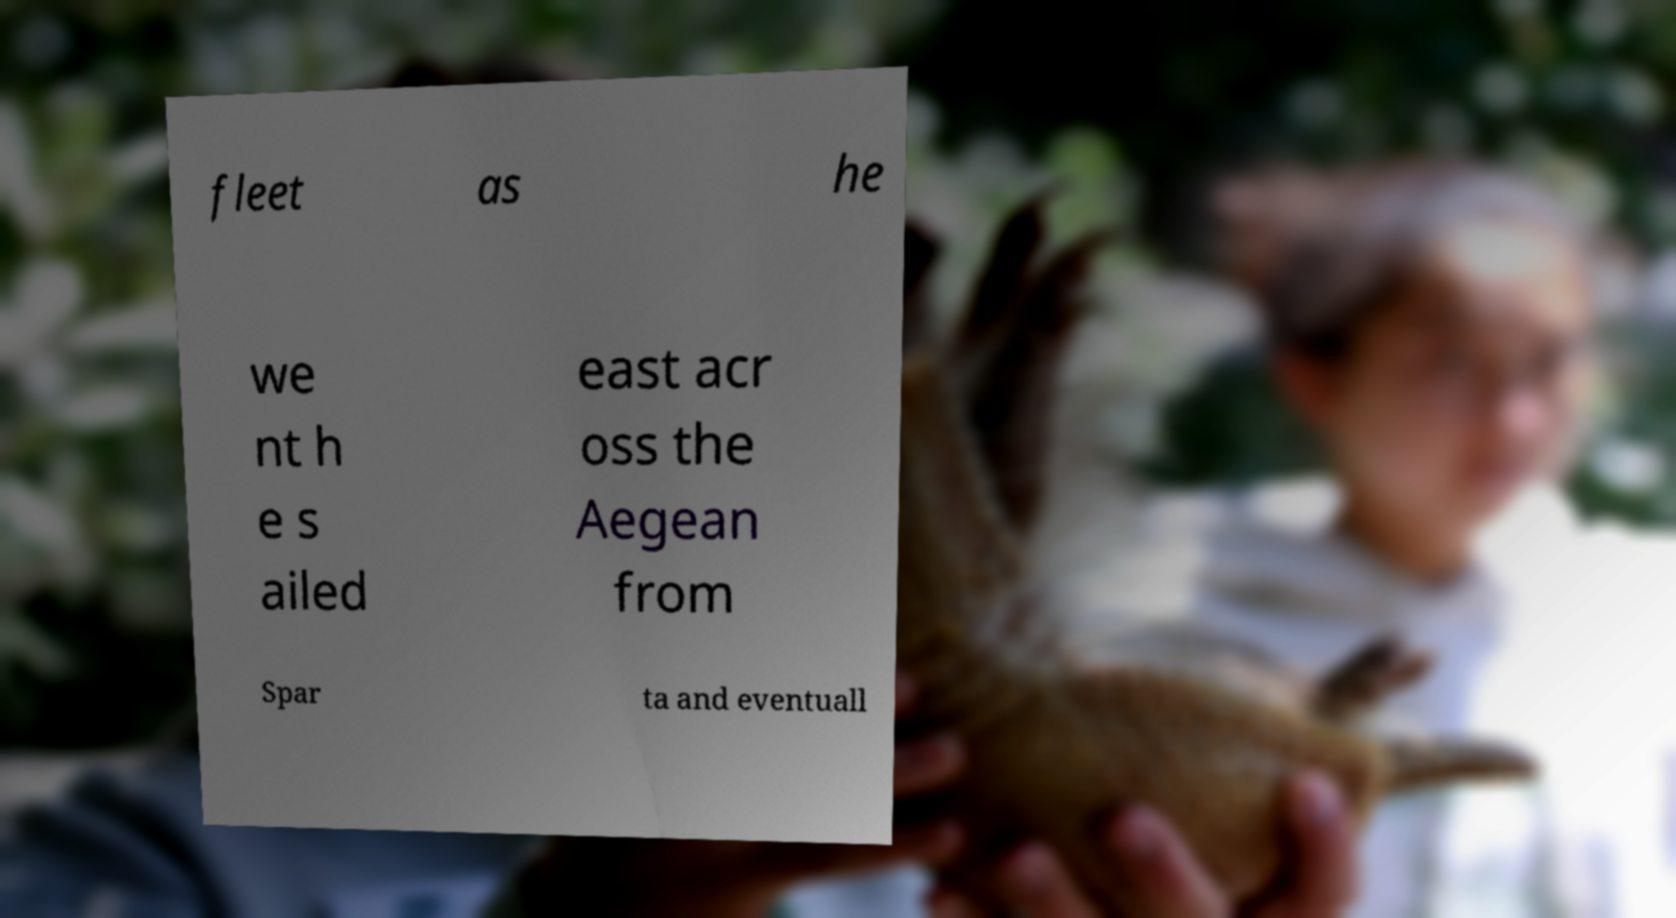I need the written content from this picture converted into text. Can you do that? fleet as he we nt h e s ailed east acr oss the Aegean from Spar ta and eventuall 